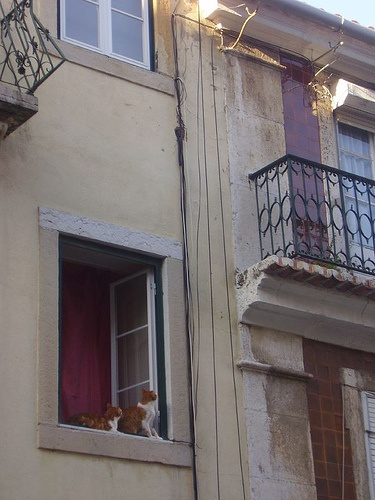Describe the objects in this image and their specific colors. I can see cat in gray, maroon, and black tones and cat in gray, maroon, black, and darkgray tones in this image. 